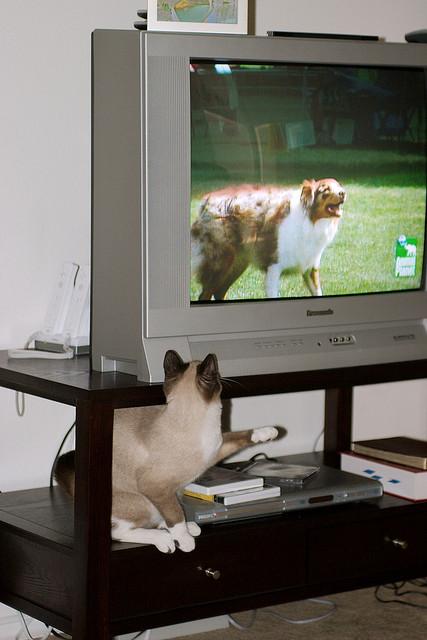What animal is on the TV screen?
Concise answer only. Dog. Which animal is live?
Write a very short answer. Cat. Is there a DVD player in the picture?
Short answer required. Yes. 